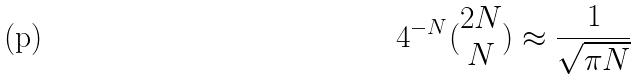<formula> <loc_0><loc_0><loc_500><loc_500>4 ^ { - N } ( \begin{matrix} 2 N \\ N \end{matrix} ) \approx \frac { 1 } { \sqrt { \pi N } }</formula> 